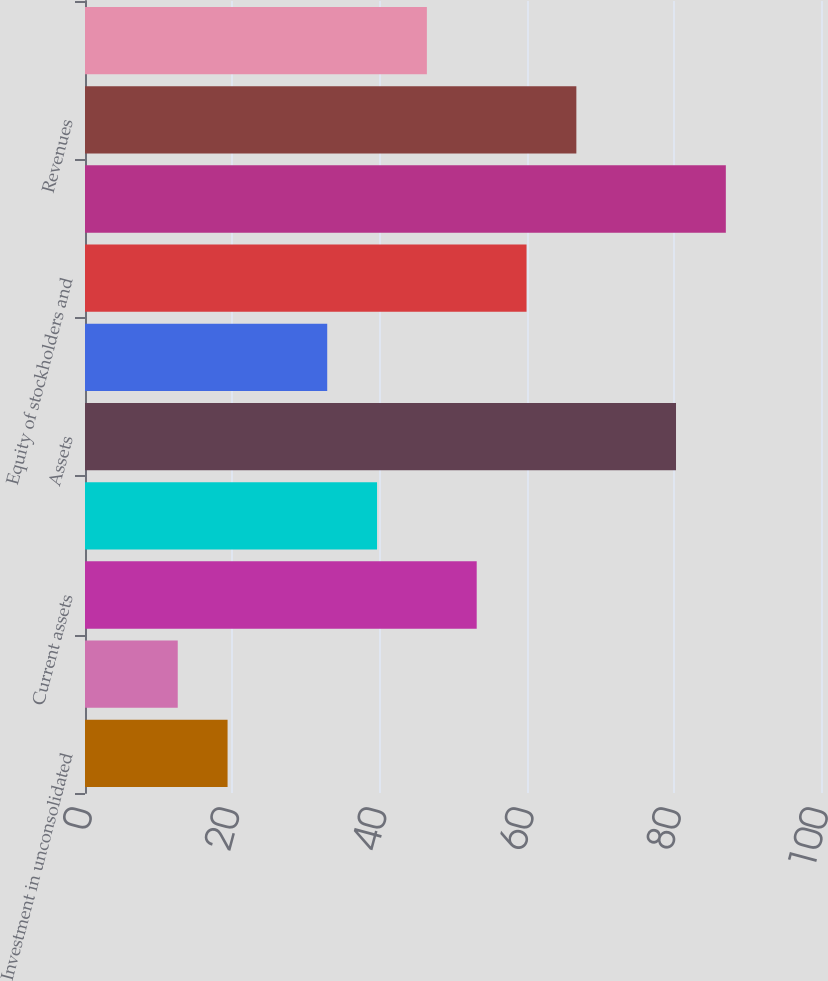Convert chart. <chart><loc_0><loc_0><loc_500><loc_500><bar_chart><fcel>Investment in unconsolidated<fcel>Equity in net assets of<fcel>Current assets<fcel>Other assets<fcel>Assets<fcel>Long-term liabilities<fcel>Equity of stockholders and<fcel>Liabilities and equity<fcel>Revenues<fcel>Expenses<nl><fcel>19.37<fcel>12.6<fcel>53.22<fcel>39.68<fcel>80.3<fcel>32.91<fcel>59.99<fcel>87.07<fcel>66.76<fcel>46.45<nl></chart> 